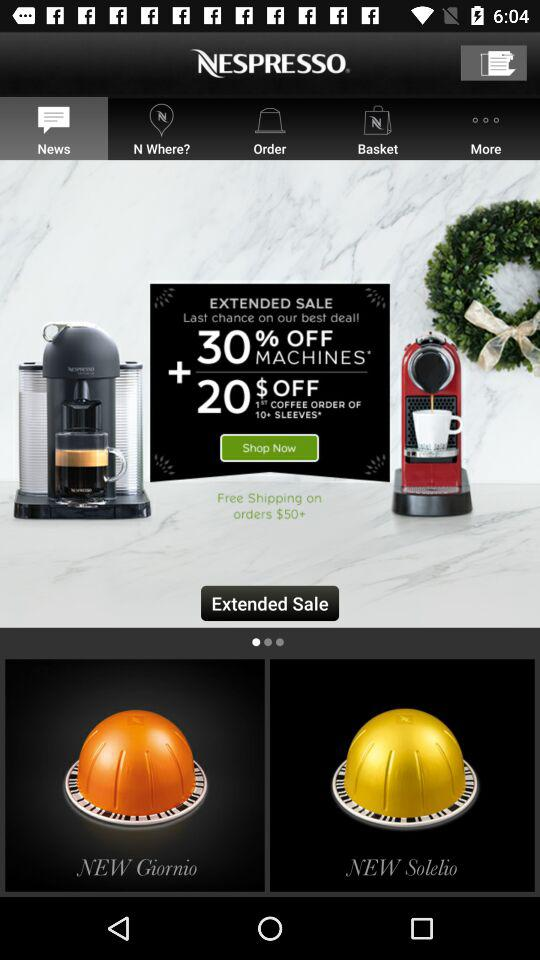What is the name of the application? The name of the application is "NESPRESSO". 